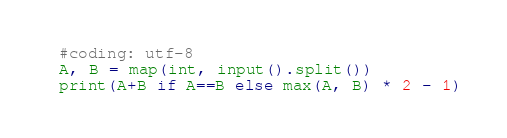Convert code to text. <code><loc_0><loc_0><loc_500><loc_500><_Python_>#coding: utf-8
A, B = map(int, input().split())
print(A+B if A==B else max(A, B) * 2 - 1)</code> 